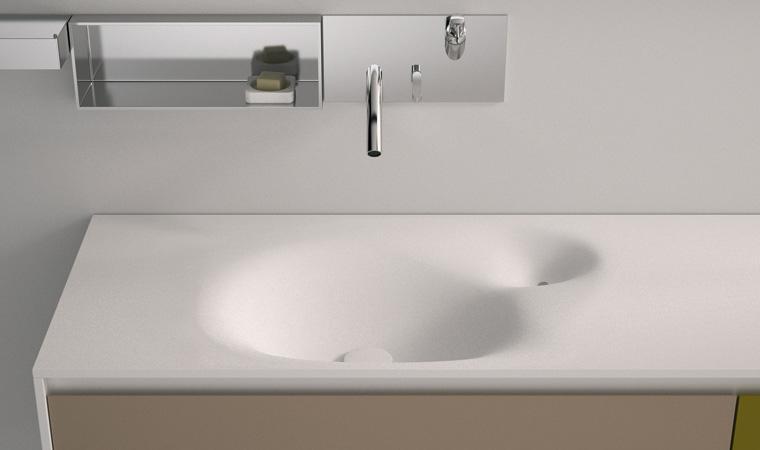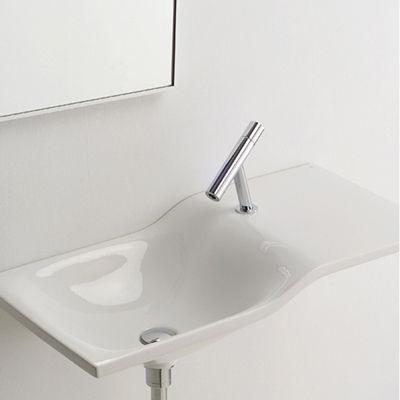The first image is the image on the left, the second image is the image on the right. Given the left and right images, does the statement "At least one of the images shows a washbasin on a wooden shelf." hold true? Answer yes or no. No. 